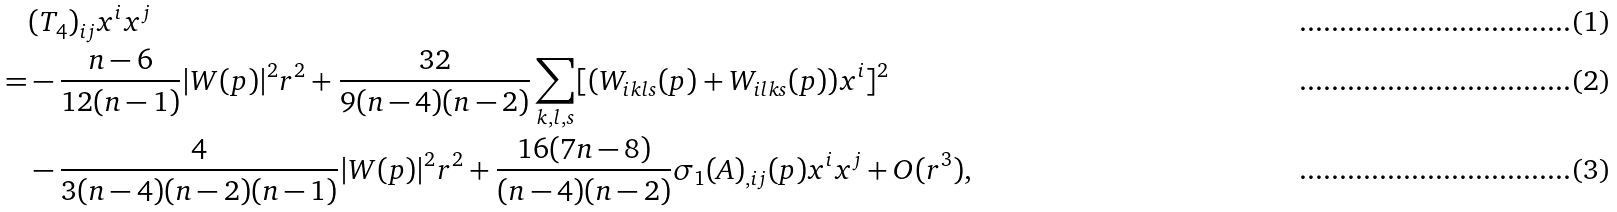<formula> <loc_0><loc_0><loc_500><loc_500>& ( T _ { 4 } ) _ { i j } x ^ { i } x ^ { j } \\ = & - \frac { n - 6 } { 1 2 ( n - 1 ) } | W ( p ) | ^ { 2 } r ^ { 2 } + \frac { 3 2 } { 9 ( n - 4 ) ( n - 2 ) } \sum _ { k , l , s } [ ( W _ { i k l s } ( p ) + W _ { i l k s } ( p ) ) x ^ { i } ] ^ { 2 } \\ & - \frac { 4 } { 3 ( n - 4 ) ( n - 2 ) ( n - 1 ) } | W ( p ) | ^ { 2 } r ^ { 2 } + \frac { 1 6 ( 7 n - 8 ) } { ( n - 4 ) ( n - 2 ) } \sigma _ { 1 } ( A ) _ { , i j } ( p ) x ^ { i } x ^ { j } + O ( r ^ { 3 } ) ,</formula> 